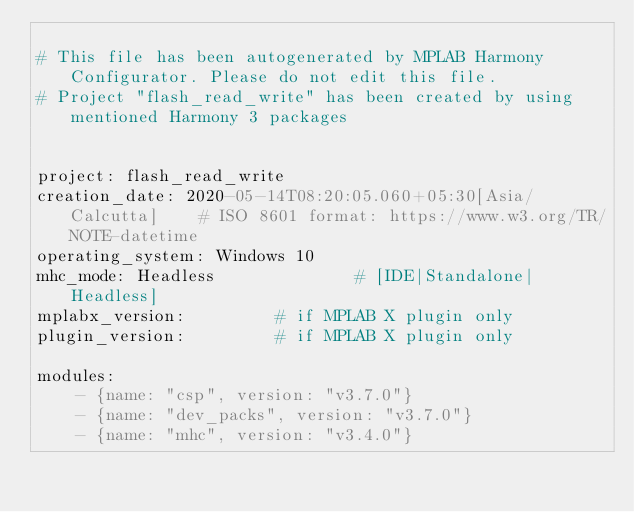Convert code to text. <code><loc_0><loc_0><loc_500><loc_500><_YAML_>
# This file has been autogenerated by MPLAB Harmony Configurator. Please do not edit this file.
# Project "flash_read_write" has been created by using mentioned Harmony 3 packages


project: flash_read_write
creation_date: 2020-05-14T08:20:05.060+05:30[Asia/Calcutta]    # ISO 8601 format: https://www.w3.org/TR/NOTE-datetime
operating_system: Windows 10
mhc_mode: Headless              # [IDE|Standalone|Headless]
mplabx_version:         # if MPLAB X plugin only
plugin_version:         # if MPLAB X plugin only

modules:
    - {name: "csp", version: "v3.7.0"}
    - {name: "dev_packs", version: "v3.7.0"}
    - {name: "mhc", version: "v3.4.0"}
</code> 